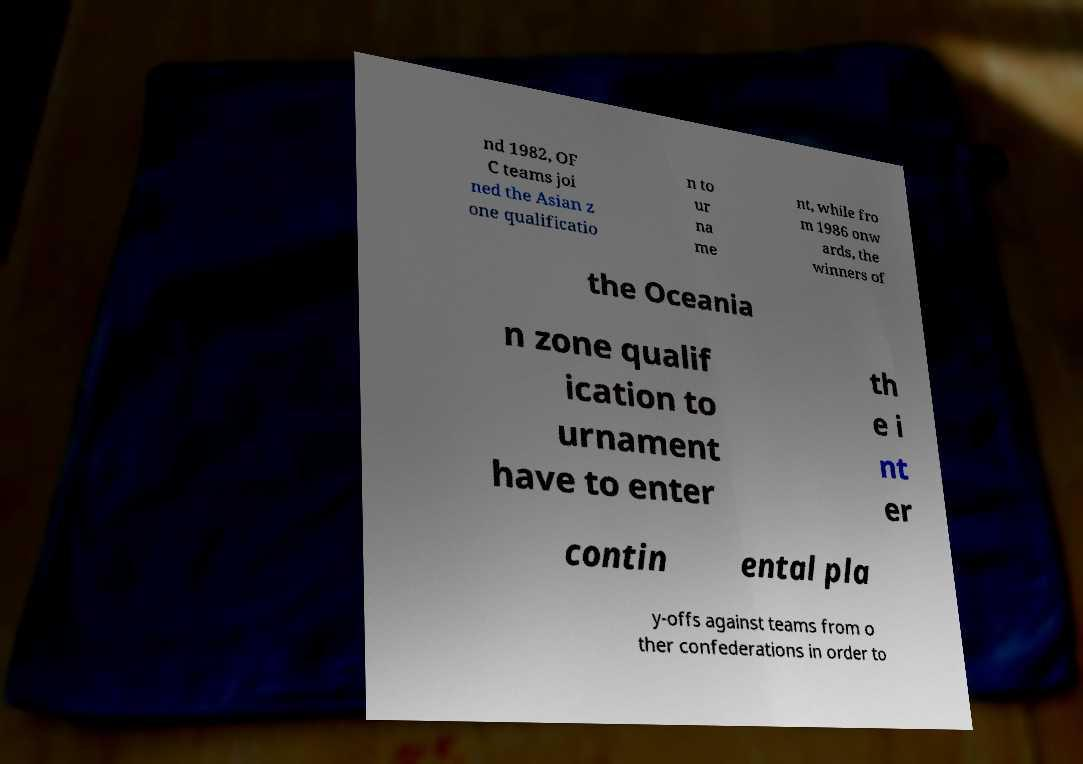Please read and relay the text visible in this image. What does it say? nd 1982, OF C teams joi ned the Asian z one qualificatio n to ur na me nt, while fro m 1986 onw ards, the winners of the Oceania n zone qualif ication to urnament have to enter th e i nt er contin ental pla y-offs against teams from o ther confederations in order to 